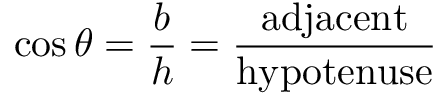<formula> <loc_0><loc_0><loc_500><loc_500>\cos \theta = { \frac { b } { h } } = { \frac { a d j a c e n t } { h y p o t e n u s e } }</formula> 